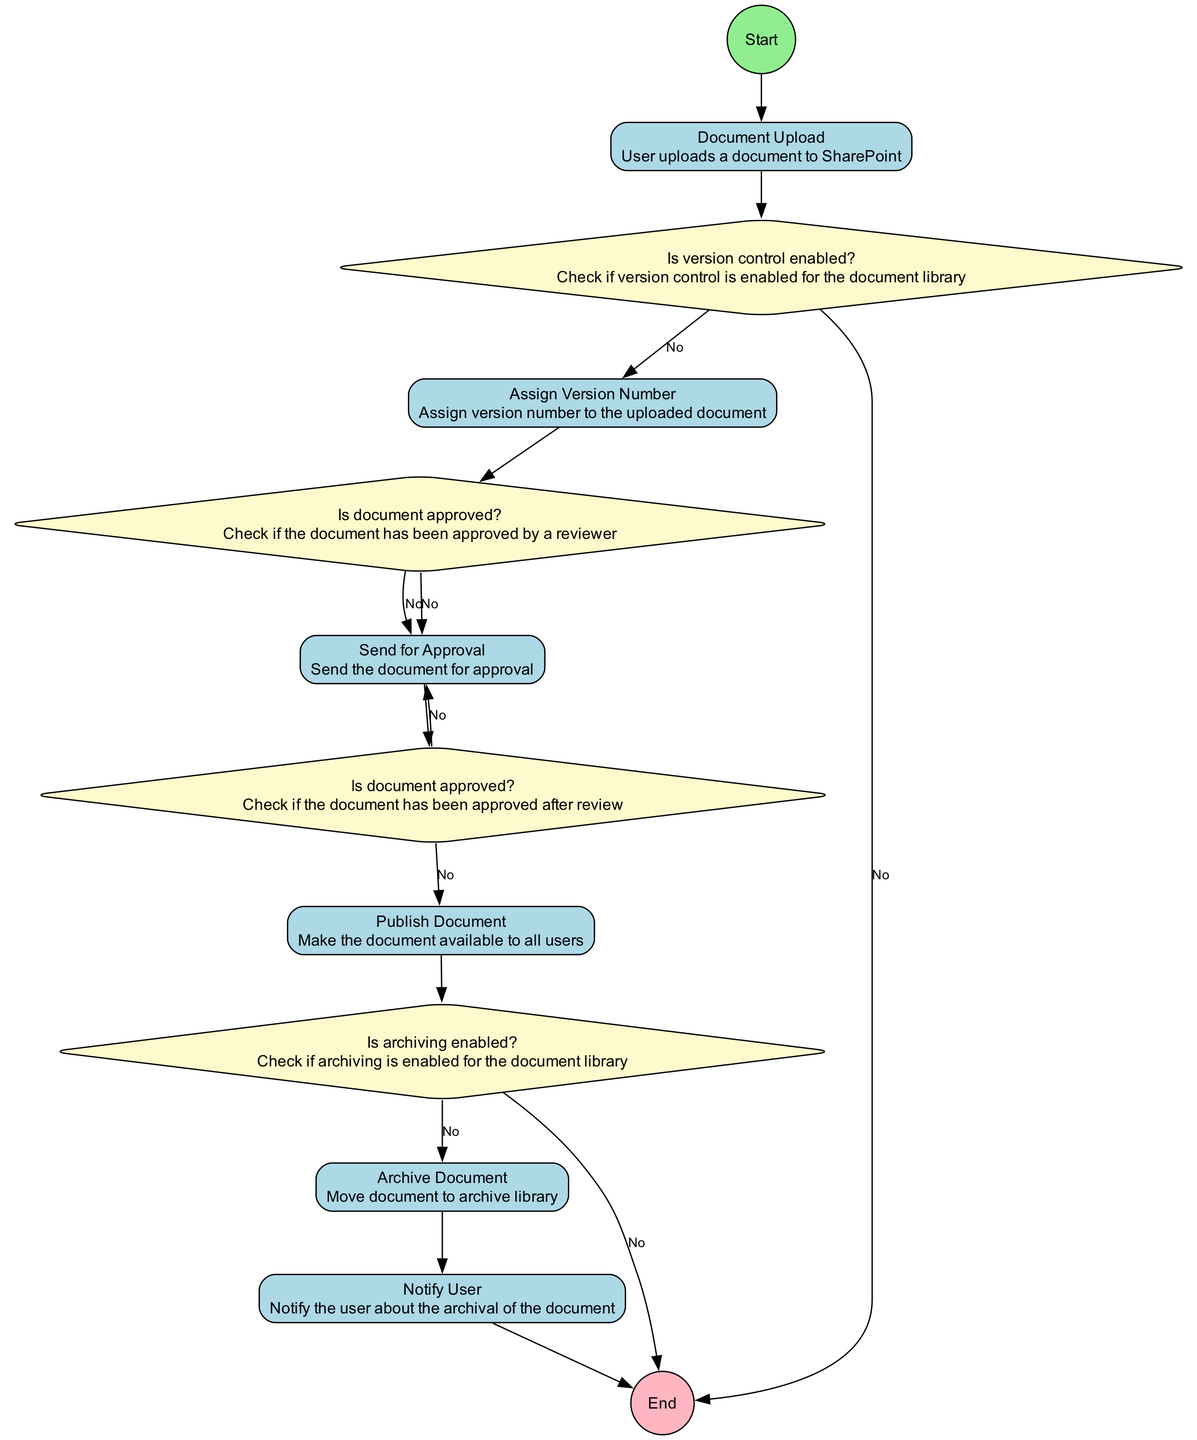What is the first action in the workflow? The first action in the workflow is "Document Upload", which is the first action after the "Start" node.
Answer: Document Upload How many decision nodes are present in the diagram? The diagram contains four decision nodes: "Is version control enabled?", "Is document approved?" (first occurrence), "Is document approved?" (second occurrence), and "Is archiving enabled?".
Answer: Four What happens if version control is not enabled? If version control is not enabled, as indicated by a "No" decision from "Is version control enabled?", the workflow ends without any further actions, resulting in termination of the process.
Answer: End Which action follows after a document is successfully approved? After a document is successfully approved, which is indicated by a "Yes" decision to "Is document approved?", the action that follows is "Publish Document".
Answer: Publish Document How does the workflow proceed if a document is not approved after review? If the document is not approved after review, indicated by a "No" decision from the second "Is document approved?", the action taken is "Send for Approval" again, looping back to seek approval.
Answer: Send for Approval What is the final action taken in the workflow? The final action in the workflow is "Notify User", which comes before the "End" node.
Answer: Notify User If archiving is not enabled, what action follows the decision? If archiving is not enabled, indicated by a "No" decision from "Is archiving enabled?", the workflow leads directly to the "End" without archiving the document.
Answer: End Which action is taken immediately after a document upload if version control is enabled? If version control is enabled, indicated by a "Yes" decision from "Is version control enabled?", the immediate action taken is "Assign Version Number".
Answer: Assign Version Number What indicates the need to send a document for approval in this workflow? The need to send a document for approval is indicated by the action "Send for Approval", which occurs if the document is not approved initially, as shown by a "No" decision.
Answer: Send for Approval 